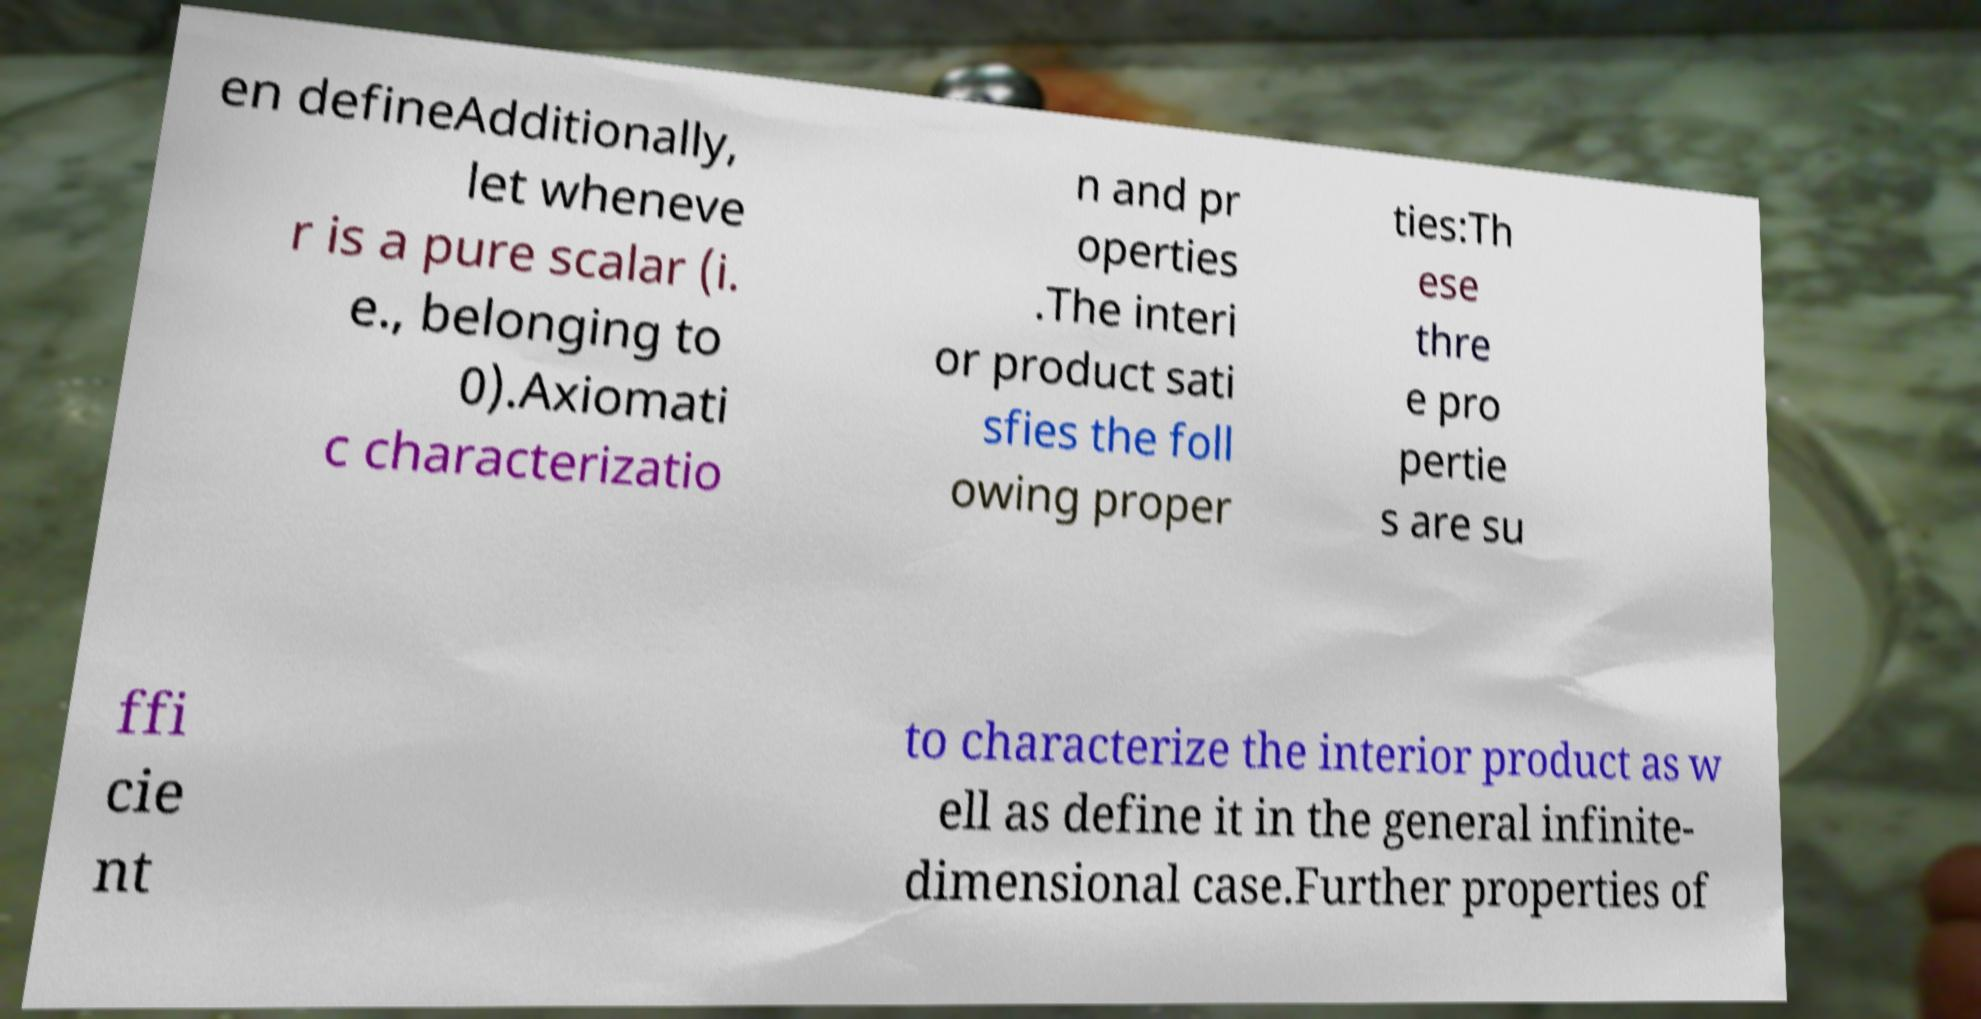Can you read and provide the text displayed in the image?This photo seems to have some interesting text. Can you extract and type it out for me? en defineAdditionally, let wheneve r is a pure scalar (i. e., belonging to 0).Axiomati c characterizatio n and pr operties .The interi or product sati sfies the foll owing proper ties:Th ese thre e pro pertie s are su ffi cie nt to characterize the interior product as w ell as define it in the general infinite- dimensional case.Further properties of 